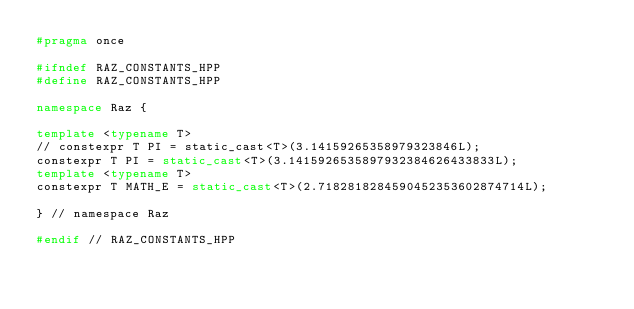<code> <loc_0><loc_0><loc_500><loc_500><_C++_>#pragma once

#ifndef RAZ_CONSTANTS_HPP
#define RAZ_CONSTANTS_HPP

namespace Raz {

template <typename T>
// constexpr T PI = static_cast<T>(3.14159265358979323846L);
constexpr T PI = static_cast<T>(3.1415926535897932384626433833L);
template <typename T>
constexpr T MATH_E = static_cast<T>(2.7182818284590452353602874714L);

} // namespace Raz

#endif // RAZ_CONSTANTS_HPP
</code> 